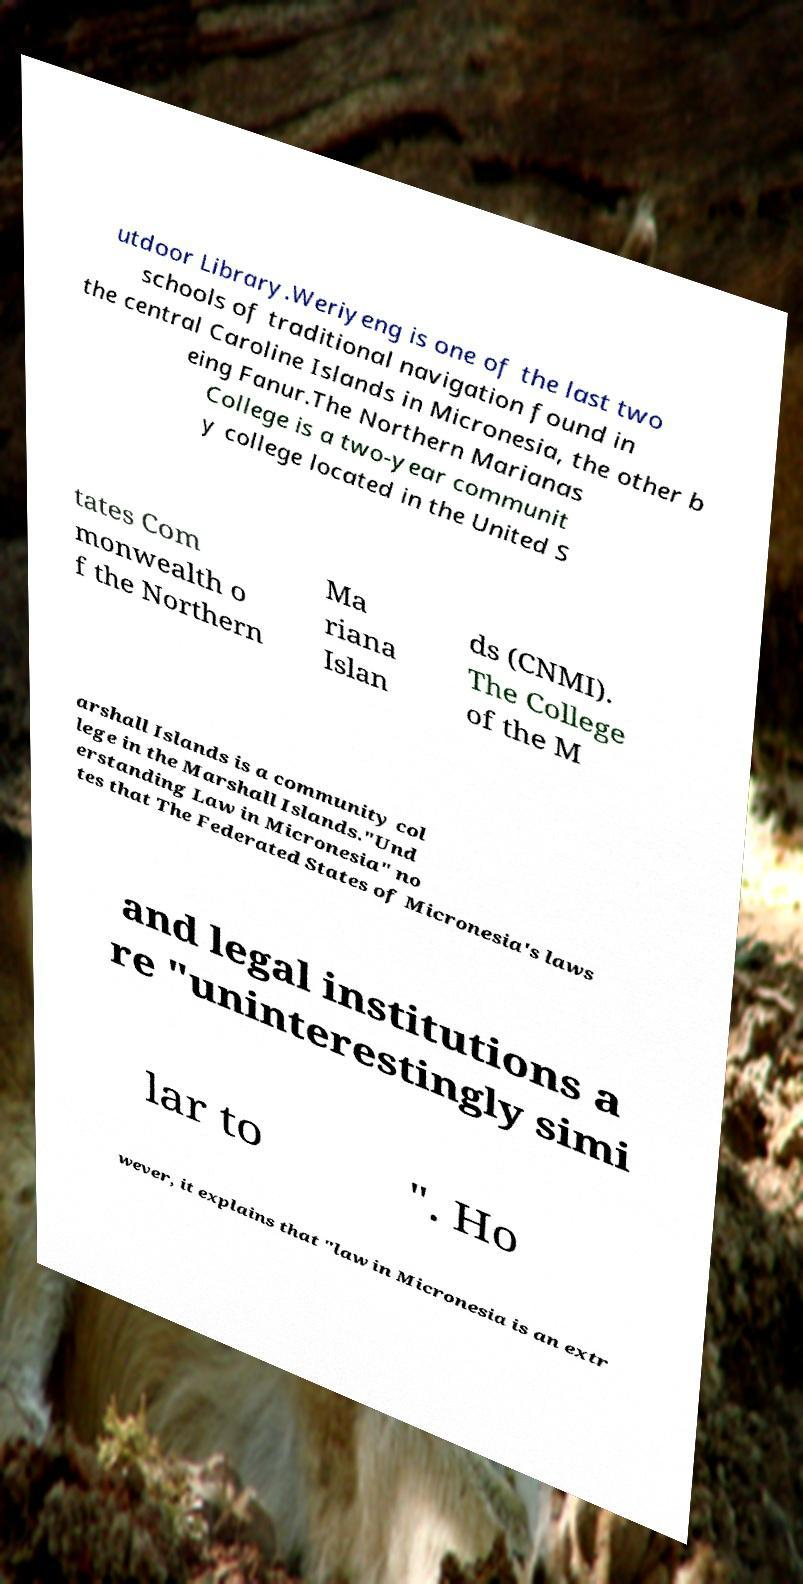Can you read and provide the text displayed in the image?This photo seems to have some interesting text. Can you extract and type it out for me? utdoor Library.Weriyeng is one of the last two schools of traditional navigation found in the central Caroline Islands in Micronesia, the other b eing Fanur.The Northern Marianas College is a two-year communit y college located in the United S tates Com monwealth o f the Northern Ma riana Islan ds (CNMI). The College of the M arshall Islands is a community col lege in the Marshall Islands."Und erstanding Law in Micronesia" no tes that The Federated States of Micronesia's laws and legal institutions a re "uninterestingly simi lar to ". Ho wever, it explains that "law in Micronesia is an extr 